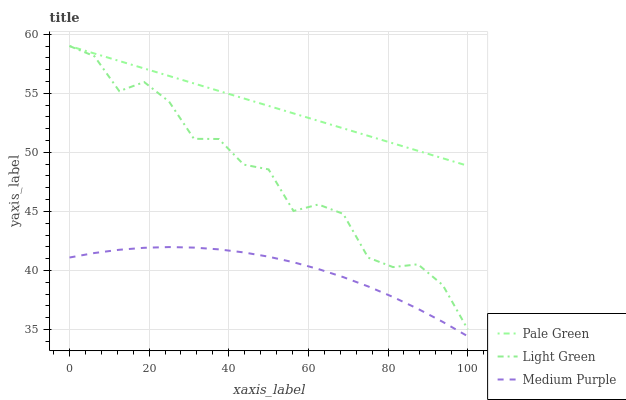Does Medium Purple have the minimum area under the curve?
Answer yes or no. Yes. Does Pale Green have the maximum area under the curve?
Answer yes or no. Yes. Does Light Green have the minimum area under the curve?
Answer yes or no. No. Does Light Green have the maximum area under the curve?
Answer yes or no. No. Is Pale Green the smoothest?
Answer yes or no. Yes. Is Light Green the roughest?
Answer yes or no. Yes. Is Light Green the smoothest?
Answer yes or no. No. Is Pale Green the roughest?
Answer yes or no. No. Does Light Green have the lowest value?
Answer yes or no. No. Does Light Green have the highest value?
Answer yes or no. Yes. Is Medium Purple less than Pale Green?
Answer yes or no. Yes. Is Pale Green greater than Medium Purple?
Answer yes or no. Yes. Does Pale Green intersect Light Green?
Answer yes or no. Yes. Is Pale Green less than Light Green?
Answer yes or no. No. Is Pale Green greater than Light Green?
Answer yes or no. No. Does Medium Purple intersect Pale Green?
Answer yes or no. No. 